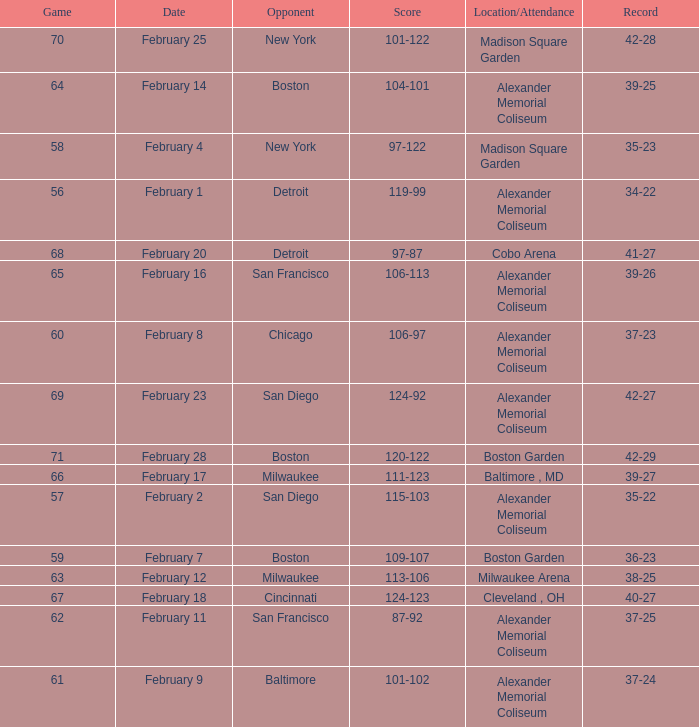What is the Game # that scored 87-92? 62.0. 